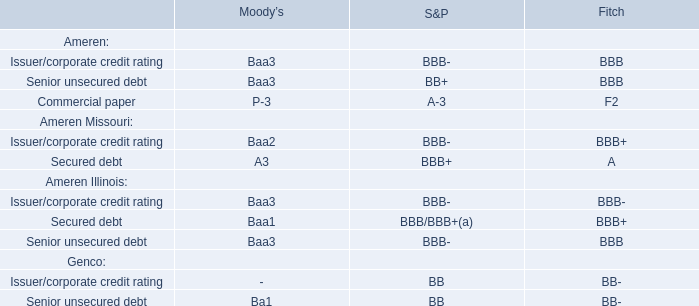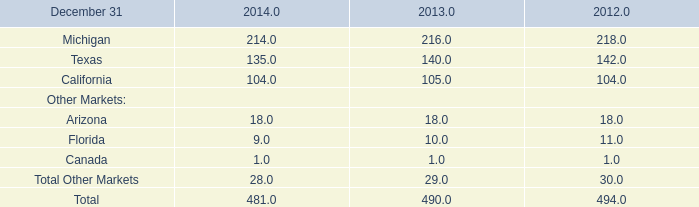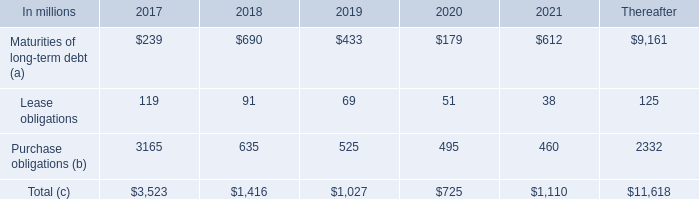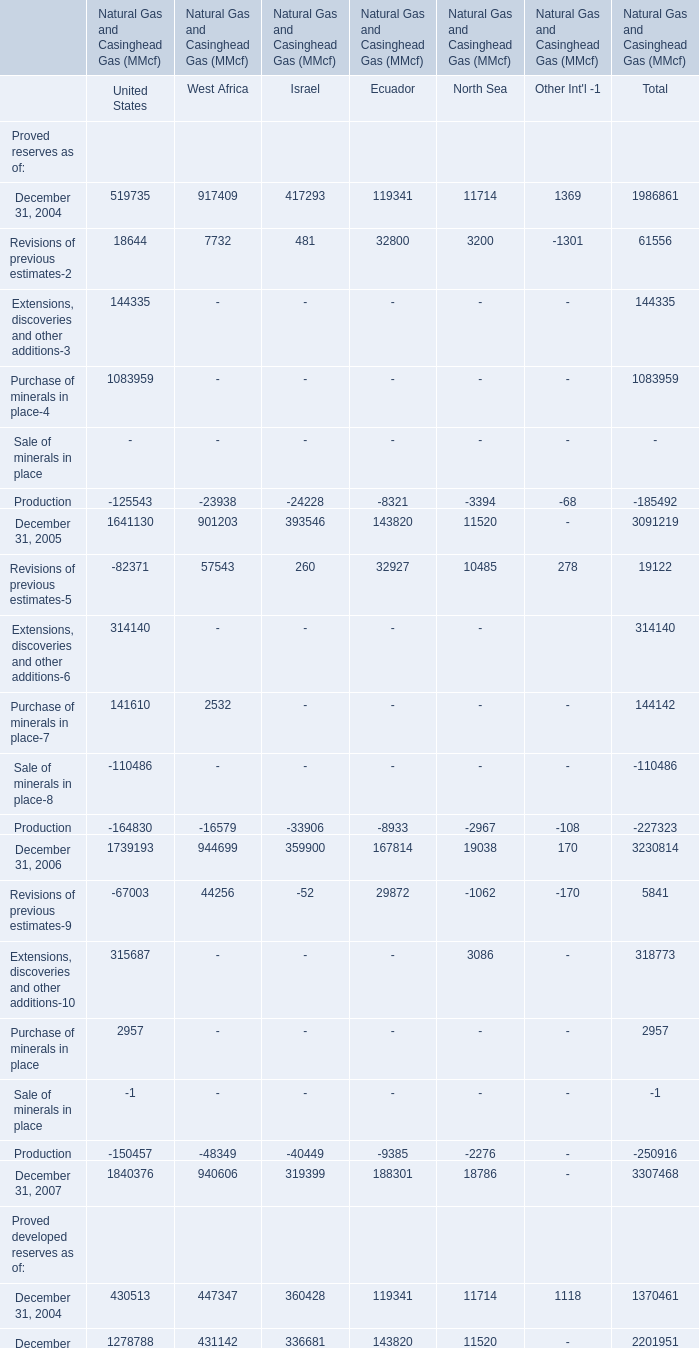What will United States be like in 2008 if it develops with the same increasing rate as current? 
Computations: ((1 + ((1259331 - 1255271) / 1255271)) * 1259331)
Answer: 1263404.13151. 